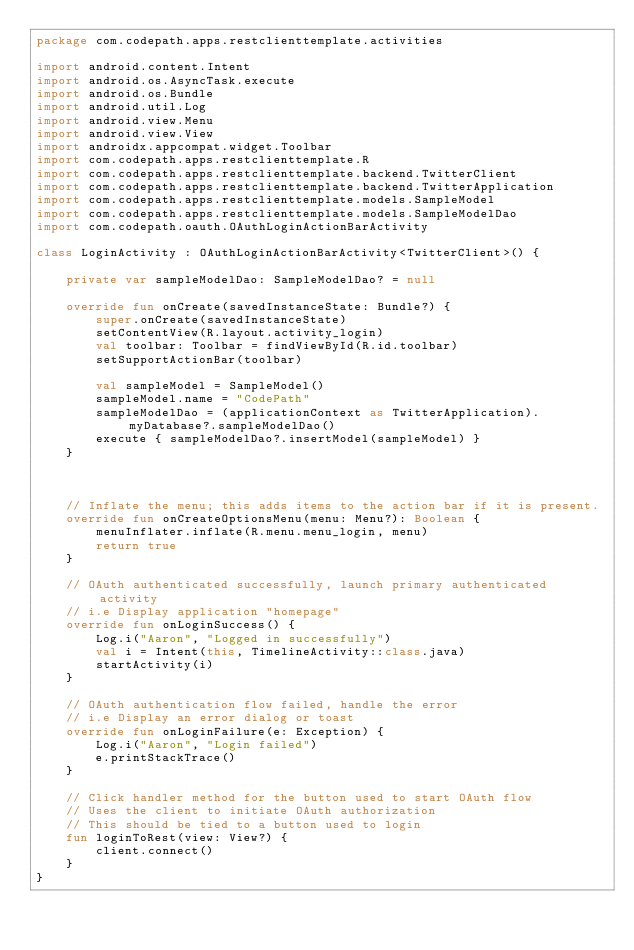<code> <loc_0><loc_0><loc_500><loc_500><_Kotlin_>package com.codepath.apps.restclienttemplate.activities

import android.content.Intent
import android.os.AsyncTask.execute
import android.os.Bundle
import android.util.Log
import android.view.Menu
import android.view.View
import androidx.appcompat.widget.Toolbar
import com.codepath.apps.restclienttemplate.R
import com.codepath.apps.restclienttemplate.backend.TwitterClient
import com.codepath.apps.restclienttemplate.backend.TwitterApplication
import com.codepath.apps.restclienttemplate.models.SampleModel
import com.codepath.apps.restclienttemplate.models.SampleModelDao
import com.codepath.oauth.OAuthLoginActionBarActivity

class LoginActivity : OAuthLoginActionBarActivity<TwitterClient>() {

    private var sampleModelDao: SampleModelDao? = null

    override fun onCreate(savedInstanceState: Bundle?) {
        super.onCreate(savedInstanceState)
        setContentView(R.layout.activity_login)
        val toolbar: Toolbar = findViewById(R.id.toolbar)
        setSupportActionBar(toolbar)

        val sampleModel = SampleModel()
        sampleModel.name = "CodePath"
        sampleModelDao = (applicationContext as TwitterApplication).myDatabase?.sampleModelDao()
        execute { sampleModelDao?.insertModel(sampleModel) }
    }



    // Inflate the menu; this adds items to the action bar if it is present.
    override fun onCreateOptionsMenu(menu: Menu?): Boolean {
        menuInflater.inflate(R.menu.menu_login, menu)
        return true
    }

    // OAuth authenticated successfully, launch primary authenticated activity
    // i.e Display application "homepage"
    override fun onLoginSuccess() {
        Log.i("Aaron", "Logged in successfully")
        val i = Intent(this, TimelineActivity::class.java)
        startActivity(i)
    }

    // OAuth authentication flow failed, handle the error
    // i.e Display an error dialog or toast
    override fun onLoginFailure(e: Exception) {
        Log.i("Aaron", "Login failed")
        e.printStackTrace()
    }

    // Click handler method for the button used to start OAuth flow
    // Uses the client to initiate OAuth authorization
    // This should be tied to a button used to login
    fun loginToRest(view: View?) {
        client.connect()
    }
}</code> 